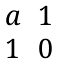Convert formula to latex. <formula><loc_0><loc_0><loc_500><loc_500>\begin{matrix} a & 1 \\ 1 & 0 \end{matrix}</formula> 